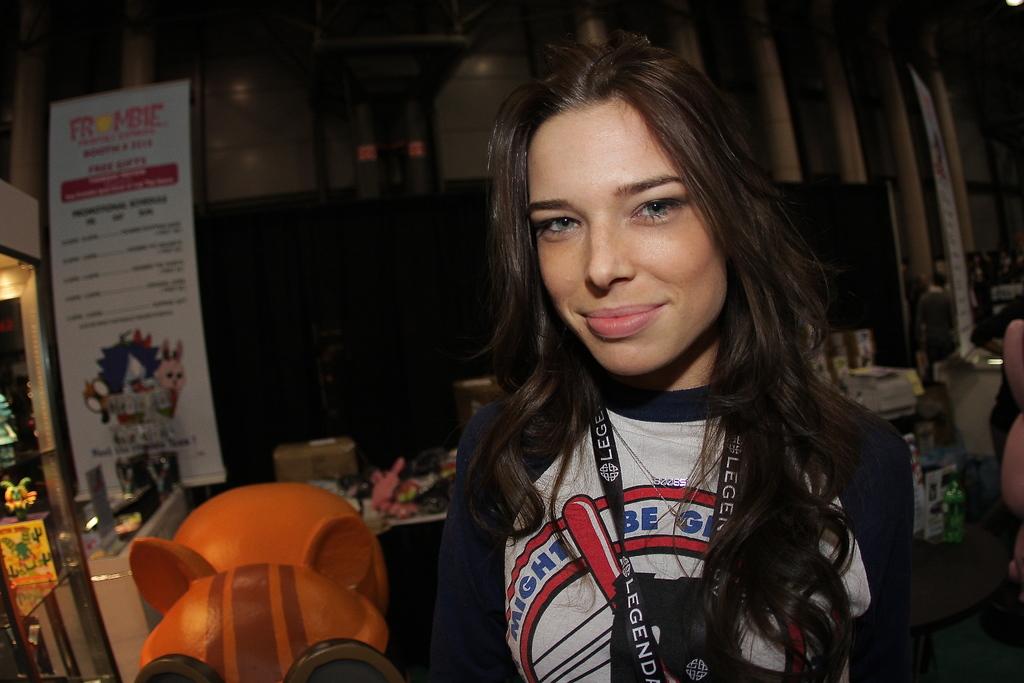What is on the girls lanyard?
Your answer should be compact. Legend. 